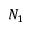<formula> <loc_0><loc_0><loc_500><loc_500>N _ { 1 }</formula> 